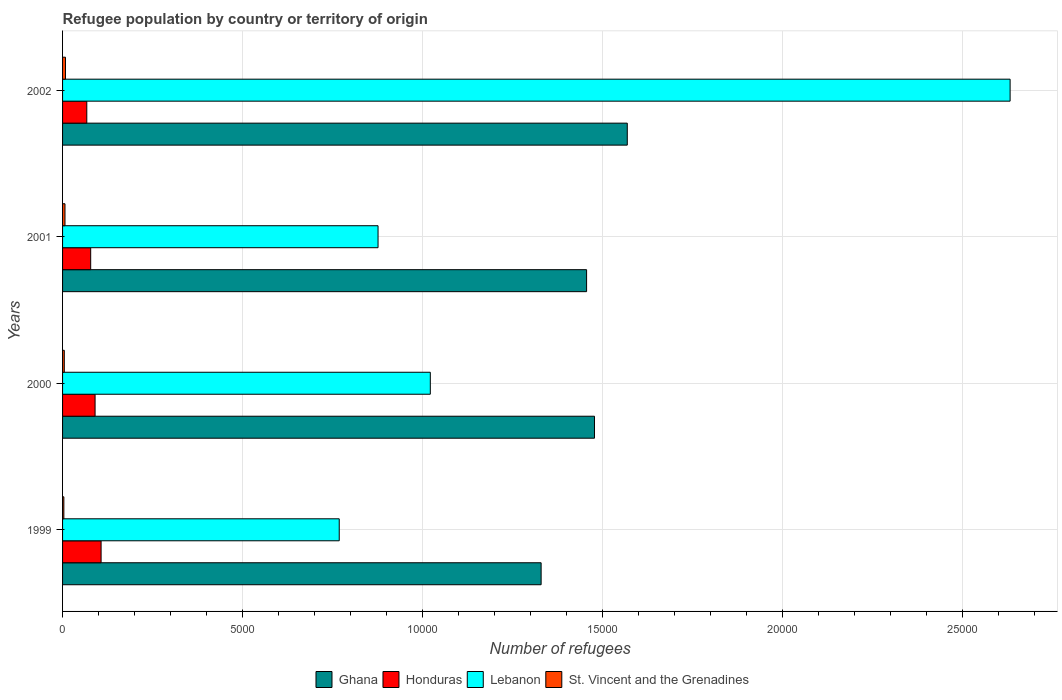How many groups of bars are there?
Offer a terse response. 4. How many bars are there on the 2nd tick from the top?
Your answer should be compact. 4. What is the label of the 4th group of bars from the top?
Ensure brevity in your answer.  1999. What is the number of refugees in Lebanon in 1999?
Ensure brevity in your answer.  7685. Across all years, what is the maximum number of refugees in Lebanon?
Ensure brevity in your answer.  2.63e+04. Across all years, what is the minimum number of refugees in Honduras?
Keep it short and to the point. 673. What is the total number of refugees in St. Vincent and the Grenadines in the graph?
Provide a short and direct response. 232. What is the difference between the number of refugees in St. Vincent and the Grenadines in 2000 and that in 2002?
Your answer should be compact. -33. What is the difference between the number of refugees in Lebanon in 2000 and the number of refugees in St. Vincent and the Grenadines in 1999?
Give a very brief answer. 1.02e+04. What is the average number of refugees in Ghana per year?
Your answer should be compact. 1.46e+04. In the year 2002, what is the difference between the number of refugees in Lebanon and number of refugees in Honduras?
Offer a terse response. 2.56e+04. In how many years, is the number of refugees in Lebanon greater than 26000 ?
Give a very brief answer. 1. What is the ratio of the number of refugees in Lebanon in 2000 to that in 2002?
Give a very brief answer. 0.39. What is the difference between the highest and the lowest number of refugees in Lebanon?
Your response must be concise. 1.86e+04. In how many years, is the number of refugees in Ghana greater than the average number of refugees in Ghana taken over all years?
Your answer should be very brief. 2. What does the 2nd bar from the top in 2000 represents?
Your answer should be very brief. Lebanon. What does the 2nd bar from the bottom in 2000 represents?
Offer a very short reply. Honduras. Is it the case that in every year, the sum of the number of refugees in St. Vincent and the Grenadines and number of refugees in Lebanon is greater than the number of refugees in Honduras?
Your answer should be very brief. Yes. Are all the bars in the graph horizontal?
Make the answer very short. Yes. How many years are there in the graph?
Provide a succinct answer. 4. Does the graph contain any zero values?
Provide a short and direct response. No. How many legend labels are there?
Give a very brief answer. 4. How are the legend labels stacked?
Your response must be concise. Horizontal. What is the title of the graph?
Your response must be concise. Refugee population by country or territory of origin. Does "Belarus" appear as one of the legend labels in the graph?
Give a very brief answer. No. What is the label or title of the X-axis?
Your answer should be compact. Number of refugees. What is the label or title of the Y-axis?
Offer a terse response. Years. What is the Number of refugees in Ghana in 1999?
Your answer should be very brief. 1.33e+04. What is the Number of refugees in Honduras in 1999?
Your answer should be compact. 1070. What is the Number of refugees in Lebanon in 1999?
Offer a terse response. 7685. What is the Number of refugees of Ghana in 2000?
Offer a very short reply. 1.48e+04. What is the Number of refugees in Honduras in 2000?
Offer a very short reply. 903. What is the Number of refugees of Lebanon in 2000?
Keep it short and to the point. 1.02e+04. What is the Number of refugees in St. Vincent and the Grenadines in 2000?
Provide a short and direct response. 48. What is the Number of refugees of Ghana in 2001?
Make the answer very short. 1.46e+04. What is the Number of refugees in Honduras in 2001?
Ensure brevity in your answer.  781. What is the Number of refugees of Lebanon in 2001?
Give a very brief answer. 8763. What is the Number of refugees of Ghana in 2002?
Offer a terse response. 1.57e+04. What is the Number of refugees in Honduras in 2002?
Your response must be concise. 673. What is the Number of refugees of Lebanon in 2002?
Make the answer very short. 2.63e+04. What is the Number of refugees in St. Vincent and the Grenadines in 2002?
Keep it short and to the point. 81. Across all years, what is the maximum Number of refugees in Ghana?
Keep it short and to the point. 1.57e+04. Across all years, what is the maximum Number of refugees in Honduras?
Provide a short and direct response. 1070. Across all years, what is the maximum Number of refugees of Lebanon?
Ensure brevity in your answer.  2.63e+04. Across all years, what is the minimum Number of refugees of Ghana?
Your answer should be very brief. 1.33e+04. Across all years, what is the minimum Number of refugees in Honduras?
Provide a succinct answer. 673. Across all years, what is the minimum Number of refugees in Lebanon?
Your response must be concise. 7685. Across all years, what is the minimum Number of refugees of St. Vincent and the Grenadines?
Offer a terse response. 36. What is the total Number of refugees of Ghana in the graph?
Ensure brevity in your answer.  5.83e+04. What is the total Number of refugees in Honduras in the graph?
Make the answer very short. 3427. What is the total Number of refugees of Lebanon in the graph?
Offer a terse response. 5.30e+04. What is the total Number of refugees in St. Vincent and the Grenadines in the graph?
Offer a terse response. 232. What is the difference between the Number of refugees in Ghana in 1999 and that in 2000?
Make the answer very short. -1482. What is the difference between the Number of refugees in Honduras in 1999 and that in 2000?
Keep it short and to the point. 167. What is the difference between the Number of refugees of Lebanon in 1999 and that in 2000?
Your answer should be very brief. -2530. What is the difference between the Number of refugees of Ghana in 1999 and that in 2001?
Keep it short and to the point. -1263. What is the difference between the Number of refugees in Honduras in 1999 and that in 2001?
Ensure brevity in your answer.  289. What is the difference between the Number of refugees of Lebanon in 1999 and that in 2001?
Give a very brief answer. -1078. What is the difference between the Number of refugees of St. Vincent and the Grenadines in 1999 and that in 2001?
Your answer should be compact. -31. What is the difference between the Number of refugees of Ghana in 1999 and that in 2002?
Offer a very short reply. -2393. What is the difference between the Number of refugees of Honduras in 1999 and that in 2002?
Offer a terse response. 397. What is the difference between the Number of refugees in Lebanon in 1999 and that in 2002?
Give a very brief answer. -1.86e+04. What is the difference between the Number of refugees of St. Vincent and the Grenadines in 1999 and that in 2002?
Make the answer very short. -45. What is the difference between the Number of refugees in Ghana in 2000 and that in 2001?
Provide a short and direct response. 219. What is the difference between the Number of refugees of Honduras in 2000 and that in 2001?
Provide a succinct answer. 122. What is the difference between the Number of refugees in Lebanon in 2000 and that in 2001?
Your response must be concise. 1452. What is the difference between the Number of refugees of St. Vincent and the Grenadines in 2000 and that in 2001?
Make the answer very short. -19. What is the difference between the Number of refugees of Ghana in 2000 and that in 2002?
Offer a very short reply. -911. What is the difference between the Number of refugees of Honduras in 2000 and that in 2002?
Your response must be concise. 230. What is the difference between the Number of refugees of Lebanon in 2000 and that in 2002?
Your response must be concise. -1.61e+04. What is the difference between the Number of refugees of St. Vincent and the Grenadines in 2000 and that in 2002?
Ensure brevity in your answer.  -33. What is the difference between the Number of refugees of Ghana in 2001 and that in 2002?
Offer a very short reply. -1130. What is the difference between the Number of refugees in Honduras in 2001 and that in 2002?
Give a very brief answer. 108. What is the difference between the Number of refugees in Lebanon in 2001 and that in 2002?
Keep it short and to the point. -1.76e+04. What is the difference between the Number of refugees of St. Vincent and the Grenadines in 2001 and that in 2002?
Provide a succinct answer. -14. What is the difference between the Number of refugees in Ghana in 1999 and the Number of refugees in Honduras in 2000?
Your answer should be compact. 1.24e+04. What is the difference between the Number of refugees of Ghana in 1999 and the Number of refugees of Lebanon in 2000?
Ensure brevity in your answer.  3078. What is the difference between the Number of refugees of Ghana in 1999 and the Number of refugees of St. Vincent and the Grenadines in 2000?
Offer a terse response. 1.32e+04. What is the difference between the Number of refugees of Honduras in 1999 and the Number of refugees of Lebanon in 2000?
Offer a terse response. -9145. What is the difference between the Number of refugees of Honduras in 1999 and the Number of refugees of St. Vincent and the Grenadines in 2000?
Ensure brevity in your answer.  1022. What is the difference between the Number of refugees in Lebanon in 1999 and the Number of refugees in St. Vincent and the Grenadines in 2000?
Give a very brief answer. 7637. What is the difference between the Number of refugees of Ghana in 1999 and the Number of refugees of Honduras in 2001?
Provide a succinct answer. 1.25e+04. What is the difference between the Number of refugees of Ghana in 1999 and the Number of refugees of Lebanon in 2001?
Provide a succinct answer. 4530. What is the difference between the Number of refugees in Ghana in 1999 and the Number of refugees in St. Vincent and the Grenadines in 2001?
Make the answer very short. 1.32e+04. What is the difference between the Number of refugees of Honduras in 1999 and the Number of refugees of Lebanon in 2001?
Your answer should be compact. -7693. What is the difference between the Number of refugees of Honduras in 1999 and the Number of refugees of St. Vincent and the Grenadines in 2001?
Offer a terse response. 1003. What is the difference between the Number of refugees of Lebanon in 1999 and the Number of refugees of St. Vincent and the Grenadines in 2001?
Offer a terse response. 7618. What is the difference between the Number of refugees in Ghana in 1999 and the Number of refugees in Honduras in 2002?
Make the answer very short. 1.26e+04. What is the difference between the Number of refugees of Ghana in 1999 and the Number of refugees of Lebanon in 2002?
Provide a succinct answer. -1.30e+04. What is the difference between the Number of refugees in Ghana in 1999 and the Number of refugees in St. Vincent and the Grenadines in 2002?
Provide a succinct answer. 1.32e+04. What is the difference between the Number of refugees in Honduras in 1999 and the Number of refugees in Lebanon in 2002?
Give a very brief answer. -2.52e+04. What is the difference between the Number of refugees in Honduras in 1999 and the Number of refugees in St. Vincent and the Grenadines in 2002?
Offer a terse response. 989. What is the difference between the Number of refugees of Lebanon in 1999 and the Number of refugees of St. Vincent and the Grenadines in 2002?
Your answer should be compact. 7604. What is the difference between the Number of refugees in Ghana in 2000 and the Number of refugees in Honduras in 2001?
Make the answer very short. 1.40e+04. What is the difference between the Number of refugees in Ghana in 2000 and the Number of refugees in Lebanon in 2001?
Provide a short and direct response. 6012. What is the difference between the Number of refugees of Ghana in 2000 and the Number of refugees of St. Vincent and the Grenadines in 2001?
Your answer should be very brief. 1.47e+04. What is the difference between the Number of refugees of Honduras in 2000 and the Number of refugees of Lebanon in 2001?
Offer a very short reply. -7860. What is the difference between the Number of refugees of Honduras in 2000 and the Number of refugees of St. Vincent and the Grenadines in 2001?
Your response must be concise. 836. What is the difference between the Number of refugees in Lebanon in 2000 and the Number of refugees in St. Vincent and the Grenadines in 2001?
Offer a terse response. 1.01e+04. What is the difference between the Number of refugees in Ghana in 2000 and the Number of refugees in Honduras in 2002?
Keep it short and to the point. 1.41e+04. What is the difference between the Number of refugees in Ghana in 2000 and the Number of refugees in Lebanon in 2002?
Ensure brevity in your answer.  -1.15e+04. What is the difference between the Number of refugees of Ghana in 2000 and the Number of refugees of St. Vincent and the Grenadines in 2002?
Provide a short and direct response. 1.47e+04. What is the difference between the Number of refugees of Honduras in 2000 and the Number of refugees of Lebanon in 2002?
Provide a succinct answer. -2.54e+04. What is the difference between the Number of refugees of Honduras in 2000 and the Number of refugees of St. Vincent and the Grenadines in 2002?
Offer a very short reply. 822. What is the difference between the Number of refugees of Lebanon in 2000 and the Number of refugees of St. Vincent and the Grenadines in 2002?
Your response must be concise. 1.01e+04. What is the difference between the Number of refugees of Ghana in 2001 and the Number of refugees of Honduras in 2002?
Ensure brevity in your answer.  1.39e+04. What is the difference between the Number of refugees of Ghana in 2001 and the Number of refugees of Lebanon in 2002?
Ensure brevity in your answer.  -1.18e+04. What is the difference between the Number of refugees of Ghana in 2001 and the Number of refugees of St. Vincent and the Grenadines in 2002?
Ensure brevity in your answer.  1.45e+04. What is the difference between the Number of refugees of Honduras in 2001 and the Number of refugees of Lebanon in 2002?
Your response must be concise. -2.55e+04. What is the difference between the Number of refugees in Honduras in 2001 and the Number of refugees in St. Vincent and the Grenadines in 2002?
Make the answer very short. 700. What is the difference between the Number of refugees in Lebanon in 2001 and the Number of refugees in St. Vincent and the Grenadines in 2002?
Your answer should be compact. 8682. What is the average Number of refugees in Ghana per year?
Provide a succinct answer. 1.46e+04. What is the average Number of refugees in Honduras per year?
Your response must be concise. 856.75. What is the average Number of refugees of Lebanon per year?
Offer a very short reply. 1.32e+04. What is the average Number of refugees in St. Vincent and the Grenadines per year?
Your response must be concise. 58. In the year 1999, what is the difference between the Number of refugees in Ghana and Number of refugees in Honduras?
Provide a short and direct response. 1.22e+04. In the year 1999, what is the difference between the Number of refugees in Ghana and Number of refugees in Lebanon?
Provide a short and direct response. 5608. In the year 1999, what is the difference between the Number of refugees of Ghana and Number of refugees of St. Vincent and the Grenadines?
Ensure brevity in your answer.  1.33e+04. In the year 1999, what is the difference between the Number of refugees of Honduras and Number of refugees of Lebanon?
Provide a succinct answer. -6615. In the year 1999, what is the difference between the Number of refugees in Honduras and Number of refugees in St. Vincent and the Grenadines?
Your response must be concise. 1034. In the year 1999, what is the difference between the Number of refugees in Lebanon and Number of refugees in St. Vincent and the Grenadines?
Provide a succinct answer. 7649. In the year 2000, what is the difference between the Number of refugees in Ghana and Number of refugees in Honduras?
Your answer should be compact. 1.39e+04. In the year 2000, what is the difference between the Number of refugees in Ghana and Number of refugees in Lebanon?
Provide a short and direct response. 4560. In the year 2000, what is the difference between the Number of refugees of Ghana and Number of refugees of St. Vincent and the Grenadines?
Your response must be concise. 1.47e+04. In the year 2000, what is the difference between the Number of refugees in Honduras and Number of refugees in Lebanon?
Keep it short and to the point. -9312. In the year 2000, what is the difference between the Number of refugees in Honduras and Number of refugees in St. Vincent and the Grenadines?
Offer a terse response. 855. In the year 2000, what is the difference between the Number of refugees of Lebanon and Number of refugees of St. Vincent and the Grenadines?
Your answer should be very brief. 1.02e+04. In the year 2001, what is the difference between the Number of refugees of Ghana and Number of refugees of Honduras?
Keep it short and to the point. 1.38e+04. In the year 2001, what is the difference between the Number of refugees of Ghana and Number of refugees of Lebanon?
Offer a terse response. 5793. In the year 2001, what is the difference between the Number of refugees in Ghana and Number of refugees in St. Vincent and the Grenadines?
Your answer should be compact. 1.45e+04. In the year 2001, what is the difference between the Number of refugees in Honduras and Number of refugees in Lebanon?
Your response must be concise. -7982. In the year 2001, what is the difference between the Number of refugees of Honduras and Number of refugees of St. Vincent and the Grenadines?
Offer a very short reply. 714. In the year 2001, what is the difference between the Number of refugees in Lebanon and Number of refugees in St. Vincent and the Grenadines?
Your answer should be compact. 8696. In the year 2002, what is the difference between the Number of refugees of Ghana and Number of refugees of Honduras?
Keep it short and to the point. 1.50e+04. In the year 2002, what is the difference between the Number of refugees of Ghana and Number of refugees of Lebanon?
Offer a terse response. -1.06e+04. In the year 2002, what is the difference between the Number of refugees in Ghana and Number of refugees in St. Vincent and the Grenadines?
Offer a terse response. 1.56e+04. In the year 2002, what is the difference between the Number of refugees in Honduras and Number of refugees in Lebanon?
Ensure brevity in your answer.  -2.56e+04. In the year 2002, what is the difference between the Number of refugees of Honduras and Number of refugees of St. Vincent and the Grenadines?
Offer a very short reply. 592. In the year 2002, what is the difference between the Number of refugees in Lebanon and Number of refugees in St. Vincent and the Grenadines?
Ensure brevity in your answer.  2.62e+04. What is the ratio of the Number of refugees in Ghana in 1999 to that in 2000?
Offer a very short reply. 0.9. What is the ratio of the Number of refugees of Honduras in 1999 to that in 2000?
Provide a succinct answer. 1.18. What is the ratio of the Number of refugees in Lebanon in 1999 to that in 2000?
Ensure brevity in your answer.  0.75. What is the ratio of the Number of refugees in Ghana in 1999 to that in 2001?
Give a very brief answer. 0.91. What is the ratio of the Number of refugees of Honduras in 1999 to that in 2001?
Ensure brevity in your answer.  1.37. What is the ratio of the Number of refugees of Lebanon in 1999 to that in 2001?
Ensure brevity in your answer.  0.88. What is the ratio of the Number of refugees in St. Vincent and the Grenadines in 1999 to that in 2001?
Offer a terse response. 0.54. What is the ratio of the Number of refugees of Ghana in 1999 to that in 2002?
Make the answer very short. 0.85. What is the ratio of the Number of refugees of Honduras in 1999 to that in 2002?
Keep it short and to the point. 1.59. What is the ratio of the Number of refugees in Lebanon in 1999 to that in 2002?
Provide a succinct answer. 0.29. What is the ratio of the Number of refugees in St. Vincent and the Grenadines in 1999 to that in 2002?
Your answer should be very brief. 0.44. What is the ratio of the Number of refugees of Honduras in 2000 to that in 2001?
Offer a terse response. 1.16. What is the ratio of the Number of refugees of Lebanon in 2000 to that in 2001?
Give a very brief answer. 1.17. What is the ratio of the Number of refugees in St. Vincent and the Grenadines in 2000 to that in 2001?
Your answer should be very brief. 0.72. What is the ratio of the Number of refugees in Ghana in 2000 to that in 2002?
Your answer should be compact. 0.94. What is the ratio of the Number of refugees of Honduras in 2000 to that in 2002?
Your response must be concise. 1.34. What is the ratio of the Number of refugees in Lebanon in 2000 to that in 2002?
Make the answer very short. 0.39. What is the ratio of the Number of refugees of St. Vincent and the Grenadines in 2000 to that in 2002?
Ensure brevity in your answer.  0.59. What is the ratio of the Number of refugees of Ghana in 2001 to that in 2002?
Keep it short and to the point. 0.93. What is the ratio of the Number of refugees of Honduras in 2001 to that in 2002?
Provide a short and direct response. 1.16. What is the ratio of the Number of refugees of Lebanon in 2001 to that in 2002?
Offer a very short reply. 0.33. What is the ratio of the Number of refugees of St. Vincent and the Grenadines in 2001 to that in 2002?
Make the answer very short. 0.83. What is the difference between the highest and the second highest Number of refugees of Ghana?
Your answer should be very brief. 911. What is the difference between the highest and the second highest Number of refugees of Honduras?
Offer a terse response. 167. What is the difference between the highest and the second highest Number of refugees of Lebanon?
Make the answer very short. 1.61e+04. What is the difference between the highest and the second highest Number of refugees of St. Vincent and the Grenadines?
Offer a terse response. 14. What is the difference between the highest and the lowest Number of refugees in Ghana?
Make the answer very short. 2393. What is the difference between the highest and the lowest Number of refugees of Honduras?
Make the answer very short. 397. What is the difference between the highest and the lowest Number of refugees of Lebanon?
Offer a very short reply. 1.86e+04. What is the difference between the highest and the lowest Number of refugees in St. Vincent and the Grenadines?
Provide a short and direct response. 45. 